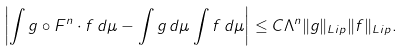Convert formula to latex. <formula><loc_0><loc_0><loc_500><loc_500>\left | \int g \circ F ^ { n } \cdot f \, d \mu - \int g \, d \mu \int f \, d \mu \right | \leq C \Lambda ^ { n } \| g \| _ { L i p } \| f \| _ { L i p } .</formula> 